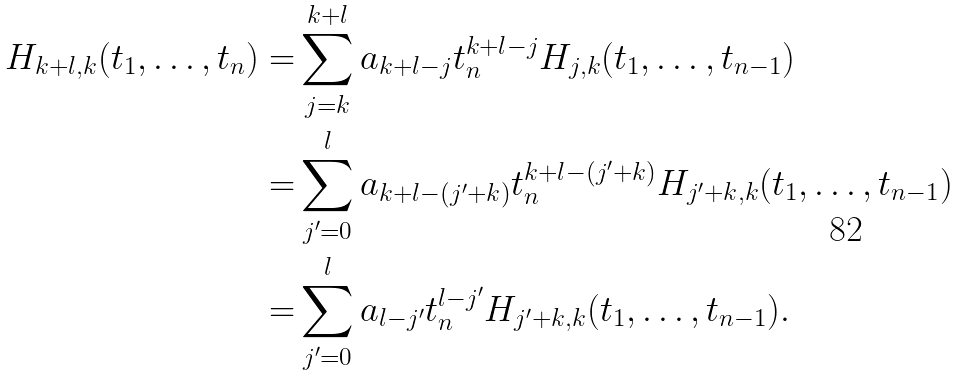Convert formula to latex. <formula><loc_0><loc_0><loc_500><loc_500>H _ { k + l , k } ( t _ { 1 } , \dots , t _ { n } ) = & \sum _ { j = k } ^ { k + l } a _ { k + l - j } t _ { n } ^ { k + l - j } H _ { j , k } ( t _ { 1 } , \dots , t _ { n - 1 } ) \\ = & \sum _ { j ^ { \prime } = 0 } ^ { l } a _ { k + l - ( j ^ { \prime } + k ) } t _ { n } ^ { k + l - ( j ^ { \prime } + k ) } H _ { j ^ { \prime } + k , k } ( t _ { 1 } , \dots , t _ { n - 1 } ) \\ = & \sum _ { j ^ { \prime } = 0 } ^ { l } a _ { l - j ^ { \prime } } t _ { n } ^ { l - j ^ { \prime } } H _ { j ^ { \prime } + k , k } ( t _ { 1 } , \dots , t _ { n - 1 } ) .</formula> 